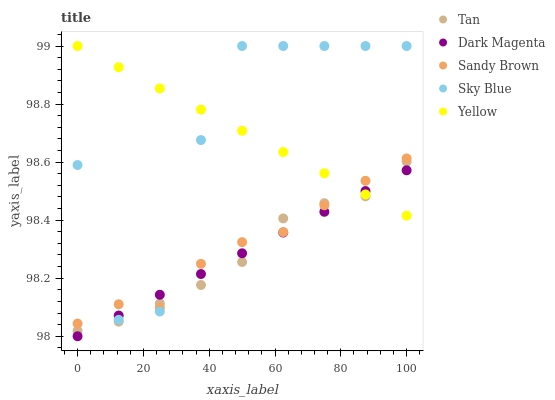Does Tan have the minimum area under the curve?
Answer yes or no. Yes. Does Yellow have the maximum area under the curve?
Answer yes or no. Yes. Does Sandy Brown have the minimum area under the curve?
Answer yes or no. No. Does Sandy Brown have the maximum area under the curve?
Answer yes or no. No. Is Dark Magenta the smoothest?
Answer yes or no. Yes. Is Sky Blue the roughest?
Answer yes or no. Yes. Is Tan the smoothest?
Answer yes or no. No. Is Tan the roughest?
Answer yes or no. No. Does Dark Magenta have the lowest value?
Answer yes or no. Yes. Does Tan have the lowest value?
Answer yes or no. No. Does Yellow have the highest value?
Answer yes or no. Yes. Does Tan have the highest value?
Answer yes or no. No. Does Sandy Brown intersect Yellow?
Answer yes or no. Yes. Is Sandy Brown less than Yellow?
Answer yes or no. No. Is Sandy Brown greater than Yellow?
Answer yes or no. No. 